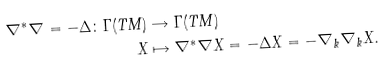<formula> <loc_0><loc_0><loc_500><loc_500>\nabla ^ { * } \nabla = - \Delta \colon \Gamma ( T M ) & \rightarrow \Gamma ( T M ) \\ X & \mapsto \nabla ^ { * } \nabla X = - \Delta X = - \nabla _ { k } \nabla _ { k } X .</formula> 